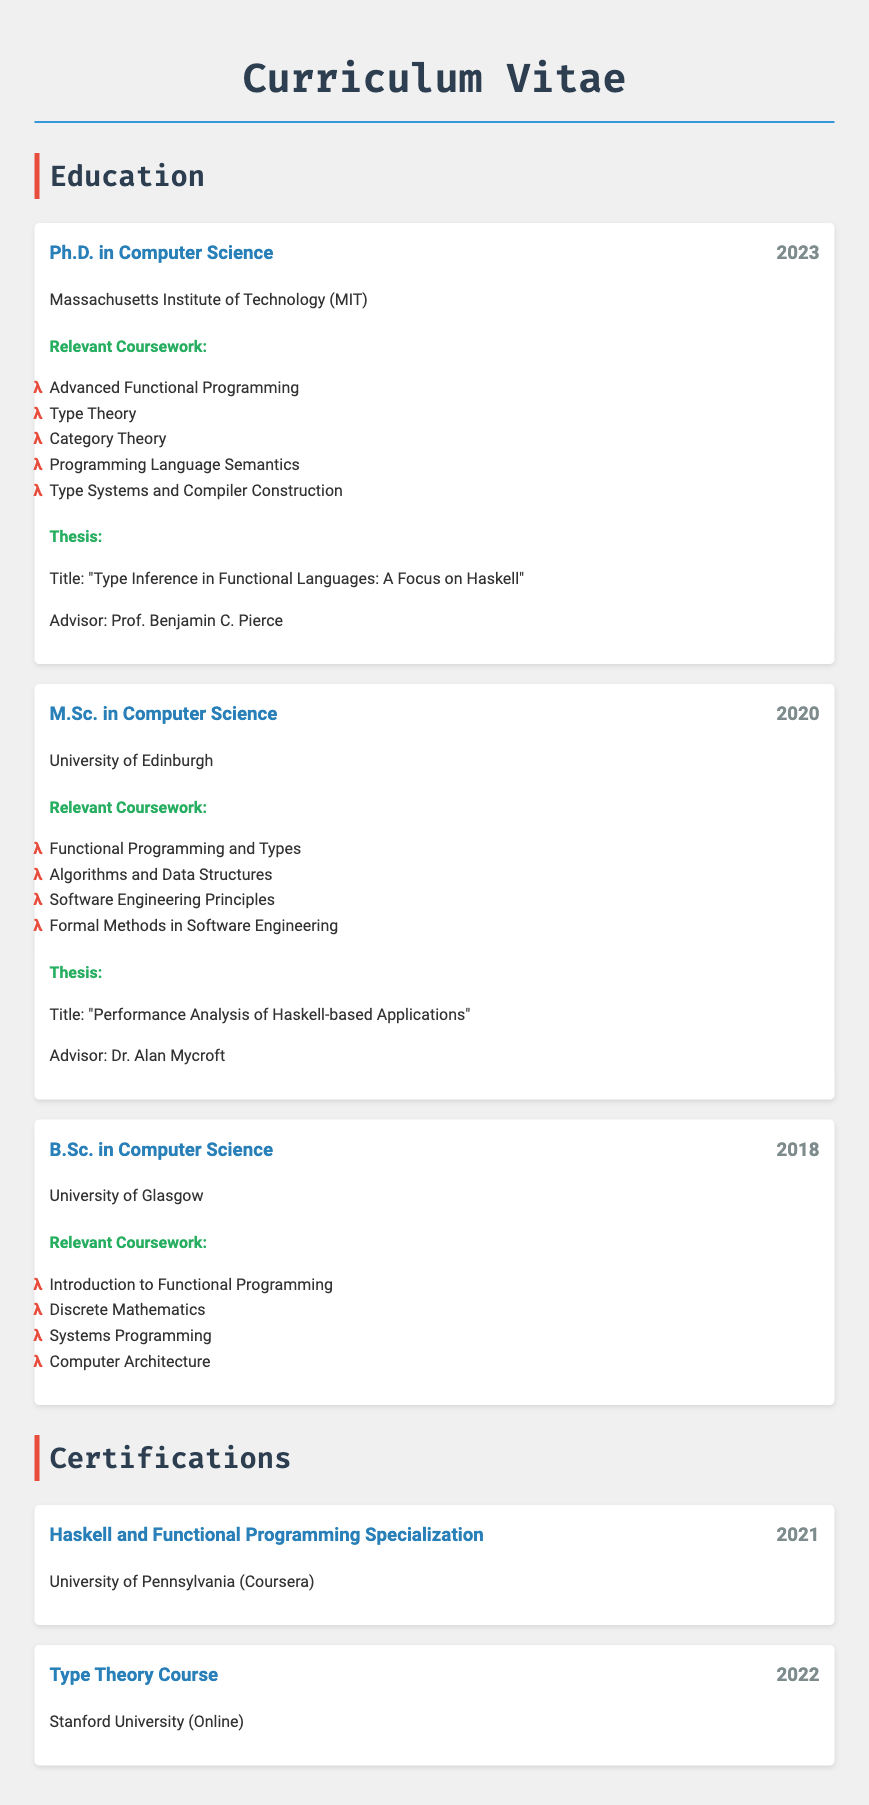What is the highest degree obtained? The highest degree listed in the document is the Ph.D. in Computer Science, which is the highest academic qualification.
Answer: Ph.D. in Computer Science Which institution awarded the most recent degree? The most recent degree listed in the document is the Ph.D., awarded by the Massachusetts Institute of Technology.
Answer: Massachusetts Institute of Technology What is the title of the Ph.D. thesis? The title of the Ph.D. thesis is specified within the thesis section of the document.
Answer: Type Inference in Functional Languages: A Focus on Haskell Who was the advisor for the M.Sc. thesis? The advisor for the M.Sc. thesis can be found in the thesis section of the document, specifically under the M.Sc. entry.
Answer: Dr. Alan Mycroft List one relevant coursework from the B.Sc. program. The relevant coursework for the B.Sc. is listed under the B.Sc. section and one of the courses is specified in the coursework subsection.
Answer: Introduction to Functional Programming What year was the certification in Haskell and Functional Programming obtained? The year for the certification is mentioned next to the certification entry in the document.
Answer: 2021 What degree did the individual obtain in 2020? The degree obtained in 2020 is specified in the education section of the document with the corresponding year.
Answer: M.Sc. in Computer Science How many degrees are listed in the education history? The answer can be obtained by counting the degree entries in the education section of the document.
Answer: Three degrees Was the Type Theory Course taken online or in person? The mode of delivery for the Type Theory Course is indicated in the certification section of the document.
Answer: Online 